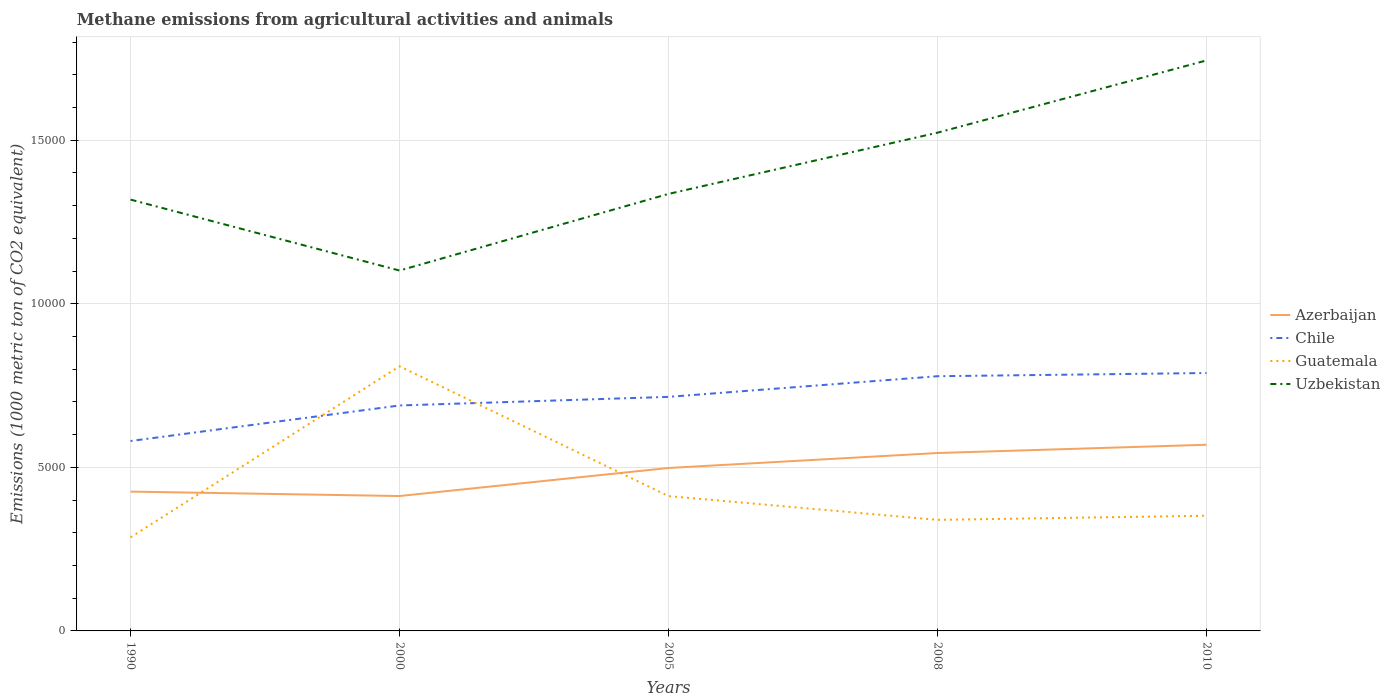How many different coloured lines are there?
Provide a short and direct response. 4. Does the line corresponding to Uzbekistan intersect with the line corresponding to Guatemala?
Offer a terse response. No. Across all years, what is the maximum amount of methane emitted in Chile?
Your answer should be very brief. 5805.8. What is the total amount of methane emitted in Guatemala in the graph?
Provide a succinct answer. -126.3. What is the difference between the highest and the second highest amount of methane emitted in Chile?
Your answer should be compact. 2077.9. What is the difference between the highest and the lowest amount of methane emitted in Chile?
Offer a terse response. 3. Is the amount of methane emitted in Azerbaijan strictly greater than the amount of methane emitted in Guatemala over the years?
Offer a terse response. No. How many lines are there?
Keep it short and to the point. 4. Are the values on the major ticks of Y-axis written in scientific E-notation?
Offer a very short reply. No. Does the graph contain grids?
Provide a succinct answer. Yes. How are the legend labels stacked?
Offer a very short reply. Vertical. What is the title of the graph?
Your response must be concise. Methane emissions from agricultural activities and animals. Does "Europe(all income levels)" appear as one of the legend labels in the graph?
Ensure brevity in your answer.  No. What is the label or title of the Y-axis?
Provide a succinct answer. Emissions (1000 metric ton of CO2 equivalent). What is the Emissions (1000 metric ton of CO2 equivalent) in Azerbaijan in 1990?
Your response must be concise. 4258.7. What is the Emissions (1000 metric ton of CO2 equivalent) in Chile in 1990?
Give a very brief answer. 5805.8. What is the Emissions (1000 metric ton of CO2 equivalent) in Guatemala in 1990?
Provide a succinct answer. 2860.2. What is the Emissions (1000 metric ton of CO2 equivalent) of Uzbekistan in 1990?
Keep it short and to the point. 1.32e+04. What is the Emissions (1000 metric ton of CO2 equivalent) in Azerbaijan in 2000?
Provide a short and direct response. 4123.5. What is the Emissions (1000 metric ton of CO2 equivalent) in Chile in 2000?
Your answer should be compact. 6891.6. What is the Emissions (1000 metric ton of CO2 equivalent) of Guatemala in 2000?
Give a very brief answer. 8089.2. What is the Emissions (1000 metric ton of CO2 equivalent) of Uzbekistan in 2000?
Ensure brevity in your answer.  1.10e+04. What is the Emissions (1000 metric ton of CO2 equivalent) in Azerbaijan in 2005?
Provide a short and direct response. 4981. What is the Emissions (1000 metric ton of CO2 equivalent) of Chile in 2005?
Offer a very short reply. 7154.5. What is the Emissions (1000 metric ton of CO2 equivalent) of Guatemala in 2005?
Ensure brevity in your answer.  4120.8. What is the Emissions (1000 metric ton of CO2 equivalent) of Uzbekistan in 2005?
Provide a succinct answer. 1.34e+04. What is the Emissions (1000 metric ton of CO2 equivalent) in Azerbaijan in 2008?
Keep it short and to the point. 5438.1. What is the Emissions (1000 metric ton of CO2 equivalent) of Chile in 2008?
Offer a terse response. 7786.1. What is the Emissions (1000 metric ton of CO2 equivalent) in Guatemala in 2008?
Your response must be concise. 3394.9. What is the Emissions (1000 metric ton of CO2 equivalent) in Uzbekistan in 2008?
Keep it short and to the point. 1.52e+04. What is the Emissions (1000 metric ton of CO2 equivalent) of Azerbaijan in 2010?
Your answer should be compact. 5691.1. What is the Emissions (1000 metric ton of CO2 equivalent) in Chile in 2010?
Provide a short and direct response. 7883.7. What is the Emissions (1000 metric ton of CO2 equivalent) in Guatemala in 2010?
Your answer should be compact. 3521.2. What is the Emissions (1000 metric ton of CO2 equivalent) of Uzbekistan in 2010?
Make the answer very short. 1.74e+04. Across all years, what is the maximum Emissions (1000 metric ton of CO2 equivalent) in Azerbaijan?
Your answer should be compact. 5691.1. Across all years, what is the maximum Emissions (1000 metric ton of CO2 equivalent) in Chile?
Provide a short and direct response. 7883.7. Across all years, what is the maximum Emissions (1000 metric ton of CO2 equivalent) in Guatemala?
Your answer should be compact. 8089.2. Across all years, what is the maximum Emissions (1000 metric ton of CO2 equivalent) in Uzbekistan?
Make the answer very short. 1.74e+04. Across all years, what is the minimum Emissions (1000 metric ton of CO2 equivalent) of Azerbaijan?
Your answer should be very brief. 4123.5. Across all years, what is the minimum Emissions (1000 metric ton of CO2 equivalent) in Chile?
Your response must be concise. 5805.8. Across all years, what is the minimum Emissions (1000 metric ton of CO2 equivalent) in Guatemala?
Give a very brief answer. 2860.2. Across all years, what is the minimum Emissions (1000 metric ton of CO2 equivalent) of Uzbekistan?
Your answer should be compact. 1.10e+04. What is the total Emissions (1000 metric ton of CO2 equivalent) in Azerbaijan in the graph?
Your answer should be very brief. 2.45e+04. What is the total Emissions (1000 metric ton of CO2 equivalent) in Chile in the graph?
Provide a succinct answer. 3.55e+04. What is the total Emissions (1000 metric ton of CO2 equivalent) in Guatemala in the graph?
Provide a short and direct response. 2.20e+04. What is the total Emissions (1000 metric ton of CO2 equivalent) of Uzbekistan in the graph?
Make the answer very short. 7.02e+04. What is the difference between the Emissions (1000 metric ton of CO2 equivalent) of Azerbaijan in 1990 and that in 2000?
Your answer should be compact. 135.2. What is the difference between the Emissions (1000 metric ton of CO2 equivalent) in Chile in 1990 and that in 2000?
Ensure brevity in your answer.  -1085.8. What is the difference between the Emissions (1000 metric ton of CO2 equivalent) in Guatemala in 1990 and that in 2000?
Give a very brief answer. -5229. What is the difference between the Emissions (1000 metric ton of CO2 equivalent) in Uzbekistan in 1990 and that in 2000?
Keep it short and to the point. 2168. What is the difference between the Emissions (1000 metric ton of CO2 equivalent) in Azerbaijan in 1990 and that in 2005?
Give a very brief answer. -722.3. What is the difference between the Emissions (1000 metric ton of CO2 equivalent) in Chile in 1990 and that in 2005?
Offer a very short reply. -1348.7. What is the difference between the Emissions (1000 metric ton of CO2 equivalent) of Guatemala in 1990 and that in 2005?
Provide a succinct answer. -1260.6. What is the difference between the Emissions (1000 metric ton of CO2 equivalent) in Uzbekistan in 1990 and that in 2005?
Keep it short and to the point. -174.6. What is the difference between the Emissions (1000 metric ton of CO2 equivalent) in Azerbaijan in 1990 and that in 2008?
Your response must be concise. -1179.4. What is the difference between the Emissions (1000 metric ton of CO2 equivalent) of Chile in 1990 and that in 2008?
Keep it short and to the point. -1980.3. What is the difference between the Emissions (1000 metric ton of CO2 equivalent) in Guatemala in 1990 and that in 2008?
Your answer should be compact. -534.7. What is the difference between the Emissions (1000 metric ton of CO2 equivalent) of Uzbekistan in 1990 and that in 2008?
Offer a very short reply. -2046.5. What is the difference between the Emissions (1000 metric ton of CO2 equivalent) of Azerbaijan in 1990 and that in 2010?
Your response must be concise. -1432.4. What is the difference between the Emissions (1000 metric ton of CO2 equivalent) in Chile in 1990 and that in 2010?
Your answer should be compact. -2077.9. What is the difference between the Emissions (1000 metric ton of CO2 equivalent) of Guatemala in 1990 and that in 2010?
Your answer should be compact. -661. What is the difference between the Emissions (1000 metric ton of CO2 equivalent) in Uzbekistan in 1990 and that in 2010?
Keep it short and to the point. -4255. What is the difference between the Emissions (1000 metric ton of CO2 equivalent) of Azerbaijan in 2000 and that in 2005?
Ensure brevity in your answer.  -857.5. What is the difference between the Emissions (1000 metric ton of CO2 equivalent) in Chile in 2000 and that in 2005?
Make the answer very short. -262.9. What is the difference between the Emissions (1000 metric ton of CO2 equivalent) in Guatemala in 2000 and that in 2005?
Ensure brevity in your answer.  3968.4. What is the difference between the Emissions (1000 metric ton of CO2 equivalent) in Uzbekistan in 2000 and that in 2005?
Offer a very short reply. -2342.6. What is the difference between the Emissions (1000 metric ton of CO2 equivalent) of Azerbaijan in 2000 and that in 2008?
Provide a succinct answer. -1314.6. What is the difference between the Emissions (1000 metric ton of CO2 equivalent) of Chile in 2000 and that in 2008?
Offer a very short reply. -894.5. What is the difference between the Emissions (1000 metric ton of CO2 equivalent) in Guatemala in 2000 and that in 2008?
Your answer should be very brief. 4694.3. What is the difference between the Emissions (1000 metric ton of CO2 equivalent) of Uzbekistan in 2000 and that in 2008?
Offer a very short reply. -4214.5. What is the difference between the Emissions (1000 metric ton of CO2 equivalent) in Azerbaijan in 2000 and that in 2010?
Keep it short and to the point. -1567.6. What is the difference between the Emissions (1000 metric ton of CO2 equivalent) in Chile in 2000 and that in 2010?
Provide a short and direct response. -992.1. What is the difference between the Emissions (1000 metric ton of CO2 equivalent) of Guatemala in 2000 and that in 2010?
Provide a succinct answer. 4568. What is the difference between the Emissions (1000 metric ton of CO2 equivalent) in Uzbekistan in 2000 and that in 2010?
Make the answer very short. -6423. What is the difference between the Emissions (1000 metric ton of CO2 equivalent) in Azerbaijan in 2005 and that in 2008?
Your answer should be compact. -457.1. What is the difference between the Emissions (1000 metric ton of CO2 equivalent) in Chile in 2005 and that in 2008?
Give a very brief answer. -631.6. What is the difference between the Emissions (1000 metric ton of CO2 equivalent) in Guatemala in 2005 and that in 2008?
Give a very brief answer. 725.9. What is the difference between the Emissions (1000 metric ton of CO2 equivalent) in Uzbekistan in 2005 and that in 2008?
Ensure brevity in your answer.  -1871.9. What is the difference between the Emissions (1000 metric ton of CO2 equivalent) of Azerbaijan in 2005 and that in 2010?
Your response must be concise. -710.1. What is the difference between the Emissions (1000 metric ton of CO2 equivalent) in Chile in 2005 and that in 2010?
Offer a very short reply. -729.2. What is the difference between the Emissions (1000 metric ton of CO2 equivalent) in Guatemala in 2005 and that in 2010?
Your response must be concise. 599.6. What is the difference between the Emissions (1000 metric ton of CO2 equivalent) of Uzbekistan in 2005 and that in 2010?
Give a very brief answer. -4080.4. What is the difference between the Emissions (1000 metric ton of CO2 equivalent) of Azerbaijan in 2008 and that in 2010?
Keep it short and to the point. -253. What is the difference between the Emissions (1000 metric ton of CO2 equivalent) of Chile in 2008 and that in 2010?
Your answer should be very brief. -97.6. What is the difference between the Emissions (1000 metric ton of CO2 equivalent) of Guatemala in 2008 and that in 2010?
Give a very brief answer. -126.3. What is the difference between the Emissions (1000 metric ton of CO2 equivalent) in Uzbekistan in 2008 and that in 2010?
Offer a very short reply. -2208.5. What is the difference between the Emissions (1000 metric ton of CO2 equivalent) of Azerbaijan in 1990 and the Emissions (1000 metric ton of CO2 equivalent) of Chile in 2000?
Provide a succinct answer. -2632.9. What is the difference between the Emissions (1000 metric ton of CO2 equivalent) of Azerbaijan in 1990 and the Emissions (1000 metric ton of CO2 equivalent) of Guatemala in 2000?
Your answer should be very brief. -3830.5. What is the difference between the Emissions (1000 metric ton of CO2 equivalent) of Azerbaijan in 1990 and the Emissions (1000 metric ton of CO2 equivalent) of Uzbekistan in 2000?
Provide a succinct answer. -6757.7. What is the difference between the Emissions (1000 metric ton of CO2 equivalent) of Chile in 1990 and the Emissions (1000 metric ton of CO2 equivalent) of Guatemala in 2000?
Provide a short and direct response. -2283.4. What is the difference between the Emissions (1000 metric ton of CO2 equivalent) of Chile in 1990 and the Emissions (1000 metric ton of CO2 equivalent) of Uzbekistan in 2000?
Keep it short and to the point. -5210.6. What is the difference between the Emissions (1000 metric ton of CO2 equivalent) of Guatemala in 1990 and the Emissions (1000 metric ton of CO2 equivalent) of Uzbekistan in 2000?
Provide a succinct answer. -8156.2. What is the difference between the Emissions (1000 metric ton of CO2 equivalent) in Azerbaijan in 1990 and the Emissions (1000 metric ton of CO2 equivalent) in Chile in 2005?
Your answer should be compact. -2895.8. What is the difference between the Emissions (1000 metric ton of CO2 equivalent) of Azerbaijan in 1990 and the Emissions (1000 metric ton of CO2 equivalent) of Guatemala in 2005?
Make the answer very short. 137.9. What is the difference between the Emissions (1000 metric ton of CO2 equivalent) in Azerbaijan in 1990 and the Emissions (1000 metric ton of CO2 equivalent) in Uzbekistan in 2005?
Ensure brevity in your answer.  -9100.3. What is the difference between the Emissions (1000 metric ton of CO2 equivalent) in Chile in 1990 and the Emissions (1000 metric ton of CO2 equivalent) in Guatemala in 2005?
Your response must be concise. 1685. What is the difference between the Emissions (1000 metric ton of CO2 equivalent) of Chile in 1990 and the Emissions (1000 metric ton of CO2 equivalent) of Uzbekistan in 2005?
Give a very brief answer. -7553.2. What is the difference between the Emissions (1000 metric ton of CO2 equivalent) in Guatemala in 1990 and the Emissions (1000 metric ton of CO2 equivalent) in Uzbekistan in 2005?
Provide a succinct answer. -1.05e+04. What is the difference between the Emissions (1000 metric ton of CO2 equivalent) of Azerbaijan in 1990 and the Emissions (1000 metric ton of CO2 equivalent) of Chile in 2008?
Provide a short and direct response. -3527.4. What is the difference between the Emissions (1000 metric ton of CO2 equivalent) in Azerbaijan in 1990 and the Emissions (1000 metric ton of CO2 equivalent) in Guatemala in 2008?
Ensure brevity in your answer.  863.8. What is the difference between the Emissions (1000 metric ton of CO2 equivalent) of Azerbaijan in 1990 and the Emissions (1000 metric ton of CO2 equivalent) of Uzbekistan in 2008?
Ensure brevity in your answer.  -1.10e+04. What is the difference between the Emissions (1000 metric ton of CO2 equivalent) in Chile in 1990 and the Emissions (1000 metric ton of CO2 equivalent) in Guatemala in 2008?
Ensure brevity in your answer.  2410.9. What is the difference between the Emissions (1000 metric ton of CO2 equivalent) in Chile in 1990 and the Emissions (1000 metric ton of CO2 equivalent) in Uzbekistan in 2008?
Offer a very short reply. -9425.1. What is the difference between the Emissions (1000 metric ton of CO2 equivalent) in Guatemala in 1990 and the Emissions (1000 metric ton of CO2 equivalent) in Uzbekistan in 2008?
Give a very brief answer. -1.24e+04. What is the difference between the Emissions (1000 metric ton of CO2 equivalent) of Azerbaijan in 1990 and the Emissions (1000 metric ton of CO2 equivalent) of Chile in 2010?
Keep it short and to the point. -3625. What is the difference between the Emissions (1000 metric ton of CO2 equivalent) in Azerbaijan in 1990 and the Emissions (1000 metric ton of CO2 equivalent) in Guatemala in 2010?
Your response must be concise. 737.5. What is the difference between the Emissions (1000 metric ton of CO2 equivalent) of Azerbaijan in 1990 and the Emissions (1000 metric ton of CO2 equivalent) of Uzbekistan in 2010?
Provide a succinct answer. -1.32e+04. What is the difference between the Emissions (1000 metric ton of CO2 equivalent) in Chile in 1990 and the Emissions (1000 metric ton of CO2 equivalent) in Guatemala in 2010?
Give a very brief answer. 2284.6. What is the difference between the Emissions (1000 metric ton of CO2 equivalent) of Chile in 1990 and the Emissions (1000 metric ton of CO2 equivalent) of Uzbekistan in 2010?
Keep it short and to the point. -1.16e+04. What is the difference between the Emissions (1000 metric ton of CO2 equivalent) of Guatemala in 1990 and the Emissions (1000 metric ton of CO2 equivalent) of Uzbekistan in 2010?
Offer a terse response. -1.46e+04. What is the difference between the Emissions (1000 metric ton of CO2 equivalent) of Azerbaijan in 2000 and the Emissions (1000 metric ton of CO2 equivalent) of Chile in 2005?
Provide a short and direct response. -3031. What is the difference between the Emissions (1000 metric ton of CO2 equivalent) of Azerbaijan in 2000 and the Emissions (1000 metric ton of CO2 equivalent) of Guatemala in 2005?
Provide a short and direct response. 2.7. What is the difference between the Emissions (1000 metric ton of CO2 equivalent) in Azerbaijan in 2000 and the Emissions (1000 metric ton of CO2 equivalent) in Uzbekistan in 2005?
Your answer should be compact. -9235.5. What is the difference between the Emissions (1000 metric ton of CO2 equivalent) in Chile in 2000 and the Emissions (1000 metric ton of CO2 equivalent) in Guatemala in 2005?
Offer a very short reply. 2770.8. What is the difference between the Emissions (1000 metric ton of CO2 equivalent) in Chile in 2000 and the Emissions (1000 metric ton of CO2 equivalent) in Uzbekistan in 2005?
Ensure brevity in your answer.  -6467.4. What is the difference between the Emissions (1000 metric ton of CO2 equivalent) of Guatemala in 2000 and the Emissions (1000 metric ton of CO2 equivalent) of Uzbekistan in 2005?
Provide a succinct answer. -5269.8. What is the difference between the Emissions (1000 metric ton of CO2 equivalent) of Azerbaijan in 2000 and the Emissions (1000 metric ton of CO2 equivalent) of Chile in 2008?
Offer a terse response. -3662.6. What is the difference between the Emissions (1000 metric ton of CO2 equivalent) in Azerbaijan in 2000 and the Emissions (1000 metric ton of CO2 equivalent) in Guatemala in 2008?
Ensure brevity in your answer.  728.6. What is the difference between the Emissions (1000 metric ton of CO2 equivalent) of Azerbaijan in 2000 and the Emissions (1000 metric ton of CO2 equivalent) of Uzbekistan in 2008?
Provide a short and direct response. -1.11e+04. What is the difference between the Emissions (1000 metric ton of CO2 equivalent) in Chile in 2000 and the Emissions (1000 metric ton of CO2 equivalent) in Guatemala in 2008?
Your response must be concise. 3496.7. What is the difference between the Emissions (1000 metric ton of CO2 equivalent) in Chile in 2000 and the Emissions (1000 metric ton of CO2 equivalent) in Uzbekistan in 2008?
Provide a succinct answer. -8339.3. What is the difference between the Emissions (1000 metric ton of CO2 equivalent) of Guatemala in 2000 and the Emissions (1000 metric ton of CO2 equivalent) of Uzbekistan in 2008?
Offer a very short reply. -7141.7. What is the difference between the Emissions (1000 metric ton of CO2 equivalent) of Azerbaijan in 2000 and the Emissions (1000 metric ton of CO2 equivalent) of Chile in 2010?
Make the answer very short. -3760.2. What is the difference between the Emissions (1000 metric ton of CO2 equivalent) in Azerbaijan in 2000 and the Emissions (1000 metric ton of CO2 equivalent) in Guatemala in 2010?
Make the answer very short. 602.3. What is the difference between the Emissions (1000 metric ton of CO2 equivalent) of Azerbaijan in 2000 and the Emissions (1000 metric ton of CO2 equivalent) of Uzbekistan in 2010?
Your answer should be very brief. -1.33e+04. What is the difference between the Emissions (1000 metric ton of CO2 equivalent) of Chile in 2000 and the Emissions (1000 metric ton of CO2 equivalent) of Guatemala in 2010?
Give a very brief answer. 3370.4. What is the difference between the Emissions (1000 metric ton of CO2 equivalent) in Chile in 2000 and the Emissions (1000 metric ton of CO2 equivalent) in Uzbekistan in 2010?
Offer a terse response. -1.05e+04. What is the difference between the Emissions (1000 metric ton of CO2 equivalent) of Guatemala in 2000 and the Emissions (1000 metric ton of CO2 equivalent) of Uzbekistan in 2010?
Offer a terse response. -9350.2. What is the difference between the Emissions (1000 metric ton of CO2 equivalent) of Azerbaijan in 2005 and the Emissions (1000 metric ton of CO2 equivalent) of Chile in 2008?
Make the answer very short. -2805.1. What is the difference between the Emissions (1000 metric ton of CO2 equivalent) in Azerbaijan in 2005 and the Emissions (1000 metric ton of CO2 equivalent) in Guatemala in 2008?
Offer a terse response. 1586.1. What is the difference between the Emissions (1000 metric ton of CO2 equivalent) of Azerbaijan in 2005 and the Emissions (1000 metric ton of CO2 equivalent) of Uzbekistan in 2008?
Offer a very short reply. -1.02e+04. What is the difference between the Emissions (1000 metric ton of CO2 equivalent) of Chile in 2005 and the Emissions (1000 metric ton of CO2 equivalent) of Guatemala in 2008?
Your response must be concise. 3759.6. What is the difference between the Emissions (1000 metric ton of CO2 equivalent) in Chile in 2005 and the Emissions (1000 metric ton of CO2 equivalent) in Uzbekistan in 2008?
Your response must be concise. -8076.4. What is the difference between the Emissions (1000 metric ton of CO2 equivalent) in Guatemala in 2005 and the Emissions (1000 metric ton of CO2 equivalent) in Uzbekistan in 2008?
Provide a short and direct response. -1.11e+04. What is the difference between the Emissions (1000 metric ton of CO2 equivalent) of Azerbaijan in 2005 and the Emissions (1000 metric ton of CO2 equivalent) of Chile in 2010?
Ensure brevity in your answer.  -2902.7. What is the difference between the Emissions (1000 metric ton of CO2 equivalent) in Azerbaijan in 2005 and the Emissions (1000 metric ton of CO2 equivalent) in Guatemala in 2010?
Offer a terse response. 1459.8. What is the difference between the Emissions (1000 metric ton of CO2 equivalent) of Azerbaijan in 2005 and the Emissions (1000 metric ton of CO2 equivalent) of Uzbekistan in 2010?
Your answer should be very brief. -1.25e+04. What is the difference between the Emissions (1000 metric ton of CO2 equivalent) in Chile in 2005 and the Emissions (1000 metric ton of CO2 equivalent) in Guatemala in 2010?
Offer a terse response. 3633.3. What is the difference between the Emissions (1000 metric ton of CO2 equivalent) of Chile in 2005 and the Emissions (1000 metric ton of CO2 equivalent) of Uzbekistan in 2010?
Your answer should be very brief. -1.03e+04. What is the difference between the Emissions (1000 metric ton of CO2 equivalent) in Guatemala in 2005 and the Emissions (1000 metric ton of CO2 equivalent) in Uzbekistan in 2010?
Your answer should be compact. -1.33e+04. What is the difference between the Emissions (1000 metric ton of CO2 equivalent) of Azerbaijan in 2008 and the Emissions (1000 metric ton of CO2 equivalent) of Chile in 2010?
Your answer should be compact. -2445.6. What is the difference between the Emissions (1000 metric ton of CO2 equivalent) in Azerbaijan in 2008 and the Emissions (1000 metric ton of CO2 equivalent) in Guatemala in 2010?
Keep it short and to the point. 1916.9. What is the difference between the Emissions (1000 metric ton of CO2 equivalent) of Azerbaijan in 2008 and the Emissions (1000 metric ton of CO2 equivalent) of Uzbekistan in 2010?
Your answer should be very brief. -1.20e+04. What is the difference between the Emissions (1000 metric ton of CO2 equivalent) in Chile in 2008 and the Emissions (1000 metric ton of CO2 equivalent) in Guatemala in 2010?
Your answer should be very brief. 4264.9. What is the difference between the Emissions (1000 metric ton of CO2 equivalent) in Chile in 2008 and the Emissions (1000 metric ton of CO2 equivalent) in Uzbekistan in 2010?
Your answer should be very brief. -9653.3. What is the difference between the Emissions (1000 metric ton of CO2 equivalent) of Guatemala in 2008 and the Emissions (1000 metric ton of CO2 equivalent) of Uzbekistan in 2010?
Keep it short and to the point. -1.40e+04. What is the average Emissions (1000 metric ton of CO2 equivalent) in Azerbaijan per year?
Give a very brief answer. 4898.48. What is the average Emissions (1000 metric ton of CO2 equivalent) of Chile per year?
Ensure brevity in your answer.  7104.34. What is the average Emissions (1000 metric ton of CO2 equivalent) in Guatemala per year?
Ensure brevity in your answer.  4397.26. What is the average Emissions (1000 metric ton of CO2 equivalent) in Uzbekistan per year?
Make the answer very short. 1.40e+04. In the year 1990, what is the difference between the Emissions (1000 metric ton of CO2 equivalent) of Azerbaijan and Emissions (1000 metric ton of CO2 equivalent) of Chile?
Keep it short and to the point. -1547.1. In the year 1990, what is the difference between the Emissions (1000 metric ton of CO2 equivalent) of Azerbaijan and Emissions (1000 metric ton of CO2 equivalent) of Guatemala?
Your response must be concise. 1398.5. In the year 1990, what is the difference between the Emissions (1000 metric ton of CO2 equivalent) of Azerbaijan and Emissions (1000 metric ton of CO2 equivalent) of Uzbekistan?
Give a very brief answer. -8925.7. In the year 1990, what is the difference between the Emissions (1000 metric ton of CO2 equivalent) of Chile and Emissions (1000 metric ton of CO2 equivalent) of Guatemala?
Your response must be concise. 2945.6. In the year 1990, what is the difference between the Emissions (1000 metric ton of CO2 equivalent) in Chile and Emissions (1000 metric ton of CO2 equivalent) in Uzbekistan?
Provide a succinct answer. -7378.6. In the year 1990, what is the difference between the Emissions (1000 metric ton of CO2 equivalent) of Guatemala and Emissions (1000 metric ton of CO2 equivalent) of Uzbekistan?
Offer a very short reply. -1.03e+04. In the year 2000, what is the difference between the Emissions (1000 metric ton of CO2 equivalent) in Azerbaijan and Emissions (1000 metric ton of CO2 equivalent) in Chile?
Give a very brief answer. -2768.1. In the year 2000, what is the difference between the Emissions (1000 metric ton of CO2 equivalent) of Azerbaijan and Emissions (1000 metric ton of CO2 equivalent) of Guatemala?
Offer a terse response. -3965.7. In the year 2000, what is the difference between the Emissions (1000 metric ton of CO2 equivalent) of Azerbaijan and Emissions (1000 metric ton of CO2 equivalent) of Uzbekistan?
Your answer should be very brief. -6892.9. In the year 2000, what is the difference between the Emissions (1000 metric ton of CO2 equivalent) of Chile and Emissions (1000 metric ton of CO2 equivalent) of Guatemala?
Provide a succinct answer. -1197.6. In the year 2000, what is the difference between the Emissions (1000 metric ton of CO2 equivalent) of Chile and Emissions (1000 metric ton of CO2 equivalent) of Uzbekistan?
Ensure brevity in your answer.  -4124.8. In the year 2000, what is the difference between the Emissions (1000 metric ton of CO2 equivalent) of Guatemala and Emissions (1000 metric ton of CO2 equivalent) of Uzbekistan?
Your answer should be very brief. -2927.2. In the year 2005, what is the difference between the Emissions (1000 metric ton of CO2 equivalent) in Azerbaijan and Emissions (1000 metric ton of CO2 equivalent) in Chile?
Your answer should be compact. -2173.5. In the year 2005, what is the difference between the Emissions (1000 metric ton of CO2 equivalent) in Azerbaijan and Emissions (1000 metric ton of CO2 equivalent) in Guatemala?
Your answer should be very brief. 860.2. In the year 2005, what is the difference between the Emissions (1000 metric ton of CO2 equivalent) of Azerbaijan and Emissions (1000 metric ton of CO2 equivalent) of Uzbekistan?
Make the answer very short. -8378. In the year 2005, what is the difference between the Emissions (1000 metric ton of CO2 equivalent) in Chile and Emissions (1000 metric ton of CO2 equivalent) in Guatemala?
Make the answer very short. 3033.7. In the year 2005, what is the difference between the Emissions (1000 metric ton of CO2 equivalent) in Chile and Emissions (1000 metric ton of CO2 equivalent) in Uzbekistan?
Ensure brevity in your answer.  -6204.5. In the year 2005, what is the difference between the Emissions (1000 metric ton of CO2 equivalent) of Guatemala and Emissions (1000 metric ton of CO2 equivalent) of Uzbekistan?
Your answer should be very brief. -9238.2. In the year 2008, what is the difference between the Emissions (1000 metric ton of CO2 equivalent) in Azerbaijan and Emissions (1000 metric ton of CO2 equivalent) in Chile?
Your response must be concise. -2348. In the year 2008, what is the difference between the Emissions (1000 metric ton of CO2 equivalent) of Azerbaijan and Emissions (1000 metric ton of CO2 equivalent) of Guatemala?
Give a very brief answer. 2043.2. In the year 2008, what is the difference between the Emissions (1000 metric ton of CO2 equivalent) in Azerbaijan and Emissions (1000 metric ton of CO2 equivalent) in Uzbekistan?
Your answer should be compact. -9792.8. In the year 2008, what is the difference between the Emissions (1000 metric ton of CO2 equivalent) in Chile and Emissions (1000 metric ton of CO2 equivalent) in Guatemala?
Offer a very short reply. 4391.2. In the year 2008, what is the difference between the Emissions (1000 metric ton of CO2 equivalent) in Chile and Emissions (1000 metric ton of CO2 equivalent) in Uzbekistan?
Offer a terse response. -7444.8. In the year 2008, what is the difference between the Emissions (1000 metric ton of CO2 equivalent) of Guatemala and Emissions (1000 metric ton of CO2 equivalent) of Uzbekistan?
Keep it short and to the point. -1.18e+04. In the year 2010, what is the difference between the Emissions (1000 metric ton of CO2 equivalent) of Azerbaijan and Emissions (1000 metric ton of CO2 equivalent) of Chile?
Ensure brevity in your answer.  -2192.6. In the year 2010, what is the difference between the Emissions (1000 metric ton of CO2 equivalent) in Azerbaijan and Emissions (1000 metric ton of CO2 equivalent) in Guatemala?
Your answer should be compact. 2169.9. In the year 2010, what is the difference between the Emissions (1000 metric ton of CO2 equivalent) in Azerbaijan and Emissions (1000 metric ton of CO2 equivalent) in Uzbekistan?
Provide a succinct answer. -1.17e+04. In the year 2010, what is the difference between the Emissions (1000 metric ton of CO2 equivalent) of Chile and Emissions (1000 metric ton of CO2 equivalent) of Guatemala?
Offer a terse response. 4362.5. In the year 2010, what is the difference between the Emissions (1000 metric ton of CO2 equivalent) of Chile and Emissions (1000 metric ton of CO2 equivalent) of Uzbekistan?
Make the answer very short. -9555.7. In the year 2010, what is the difference between the Emissions (1000 metric ton of CO2 equivalent) in Guatemala and Emissions (1000 metric ton of CO2 equivalent) in Uzbekistan?
Provide a short and direct response. -1.39e+04. What is the ratio of the Emissions (1000 metric ton of CO2 equivalent) in Azerbaijan in 1990 to that in 2000?
Give a very brief answer. 1.03. What is the ratio of the Emissions (1000 metric ton of CO2 equivalent) in Chile in 1990 to that in 2000?
Your answer should be compact. 0.84. What is the ratio of the Emissions (1000 metric ton of CO2 equivalent) in Guatemala in 1990 to that in 2000?
Give a very brief answer. 0.35. What is the ratio of the Emissions (1000 metric ton of CO2 equivalent) of Uzbekistan in 1990 to that in 2000?
Your answer should be compact. 1.2. What is the ratio of the Emissions (1000 metric ton of CO2 equivalent) in Azerbaijan in 1990 to that in 2005?
Make the answer very short. 0.85. What is the ratio of the Emissions (1000 metric ton of CO2 equivalent) of Chile in 1990 to that in 2005?
Make the answer very short. 0.81. What is the ratio of the Emissions (1000 metric ton of CO2 equivalent) in Guatemala in 1990 to that in 2005?
Offer a terse response. 0.69. What is the ratio of the Emissions (1000 metric ton of CO2 equivalent) in Uzbekistan in 1990 to that in 2005?
Provide a short and direct response. 0.99. What is the ratio of the Emissions (1000 metric ton of CO2 equivalent) in Azerbaijan in 1990 to that in 2008?
Ensure brevity in your answer.  0.78. What is the ratio of the Emissions (1000 metric ton of CO2 equivalent) of Chile in 1990 to that in 2008?
Your answer should be very brief. 0.75. What is the ratio of the Emissions (1000 metric ton of CO2 equivalent) of Guatemala in 1990 to that in 2008?
Provide a succinct answer. 0.84. What is the ratio of the Emissions (1000 metric ton of CO2 equivalent) in Uzbekistan in 1990 to that in 2008?
Your answer should be very brief. 0.87. What is the ratio of the Emissions (1000 metric ton of CO2 equivalent) in Azerbaijan in 1990 to that in 2010?
Provide a short and direct response. 0.75. What is the ratio of the Emissions (1000 metric ton of CO2 equivalent) of Chile in 1990 to that in 2010?
Your answer should be very brief. 0.74. What is the ratio of the Emissions (1000 metric ton of CO2 equivalent) of Guatemala in 1990 to that in 2010?
Offer a terse response. 0.81. What is the ratio of the Emissions (1000 metric ton of CO2 equivalent) in Uzbekistan in 1990 to that in 2010?
Offer a terse response. 0.76. What is the ratio of the Emissions (1000 metric ton of CO2 equivalent) of Azerbaijan in 2000 to that in 2005?
Ensure brevity in your answer.  0.83. What is the ratio of the Emissions (1000 metric ton of CO2 equivalent) in Chile in 2000 to that in 2005?
Offer a terse response. 0.96. What is the ratio of the Emissions (1000 metric ton of CO2 equivalent) of Guatemala in 2000 to that in 2005?
Make the answer very short. 1.96. What is the ratio of the Emissions (1000 metric ton of CO2 equivalent) in Uzbekistan in 2000 to that in 2005?
Keep it short and to the point. 0.82. What is the ratio of the Emissions (1000 metric ton of CO2 equivalent) of Azerbaijan in 2000 to that in 2008?
Your response must be concise. 0.76. What is the ratio of the Emissions (1000 metric ton of CO2 equivalent) of Chile in 2000 to that in 2008?
Make the answer very short. 0.89. What is the ratio of the Emissions (1000 metric ton of CO2 equivalent) in Guatemala in 2000 to that in 2008?
Offer a very short reply. 2.38. What is the ratio of the Emissions (1000 metric ton of CO2 equivalent) in Uzbekistan in 2000 to that in 2008?
Give a very brief answer. 0.72. What is the ratio of the Emissions (1000 metric ton of CO2 equivalent) of Azerbaijan in 2000 to that in 2010?
Give a very brief answer. 0.72. What is the ratio of the Emissions (1000 metric ton of CO2 equivalent) in Chile in 2000 to that in 2010?
Ensure brevity in your answer.  0.87. What is the ratio of the Emissions (1000 metric ton of CO2 equivalent) in Guatemala in 2000 to that in 2010?
Keep it short and to the point. 2.3. What is the ratio of the Emissions (1000 metric ton of CO2 equivalent) in Uzbekistan in 2000 to that in 2010?
Keep it short and to the point. 0.63. What is the ratio of the Emissions (1000 metric ton of CO2 equivalent) in Azerbaijan in 2005 to that in 2008?
Provide a short and direct response. 0.92. What is the ratio of the Emissions (1000 metric ton of CO2 equivalent) in Chile in 2005 to that in 2008?
Your answer should be very brief. 0.92. What is the ratio of the Emissions (1000 metric ton of CO2 equivalent) of Guatemala in 2005 to that in 2008?
Provide a short and direct response. 1.21. What is the ratio of the Emissions (1000 metric ton of CO2 equivalent) in Uzbekistan in 2005 to that in 2008?
Offer a terse response. 0.88. What is the ratio of the Emissions (1000 metric ton of CO2 equivalent) in Azerbaijan in 2005 to that in 2010?
Give a very brief answer. 0.88. What is the ratio of the Emissions (1000 metric ton of CO2 equivalent) in Chile in 2005 to that in 2010?
Offer a very short reply. 0.91. What is the ratio of the Emissions (1000 metric ton of CO2 equivalent) in Guatemala in 2005 to that in 2010?
Give a very brief answer. 1.17. What is the ratio of the Emissions (1000 metric ton of CO2 equivalent) of Uzbekistan in 2005 to that in 2010?
Keep it short and to the point. 0.77. What is the ratio of the Emissions (1000 metric ton of CO2 equivalent) in Azerbaijan in 2008 to that in 2010?
Your response must be concise. 0.96. What is the ratio of the Emissions (1000 metric ton of CO2 equivalent) of Chile in 2008 to that in 2010?
Your response must be concise. 0.99. What is the ratio of the Emissions (1000 metric ton of CO2 equivalent) in Guatemala in 2008 to that in 2010?
Keep it short and to the point. 0.96. What is the ratio of the Emissions (1000 metric ton of CO2 equivalent) of Uzbekistan in 2008 to that in 2010?
Give a very brief answer. 0.87. What is the difference between the highest and the second highest Emissions (1000 metric ton of CO2 equivalent) of Azerbaijan?
Provide a short and direct response. 253. What is the difference between the highest and the second highest Emissions (1000 metric ton of CO2 equivalent) in Chile?
Make the answer very short. 97.6. What is the difference between the highest and the second highest Emissions (1000 metric ton of CO2 equivalent) in Guatemala?
Give a very brief answer. 3968.4. What is the difference between the highest and the second highest Emissions (1000 metric ton of CO2 equivalent) in Uzbekistan?
Ensure brevity in your answer.  2208.5. What is the difference between the highest and the lowest Emissions (1000 metric ton of CO2 equivalent) in Azerbaijan?
Make the answer very short. 1567.6. What is the difference between the highest and the lowest Emissions (1000 metric ton of CO2 equivalent) of Chile?
Offer a very short reply. 2077.9. What is the difference between the highest and the lowest Emissions (1000 metric ton of CO2 equivalent) of Guatemala?
Offer a terse response. 5229. What is the difference between the highest and the lowest Emissions (1000 metric ton of CO2 equivalent) of Uzbekistan?
Ensure brevity in your answer.  6423. 